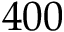<formula> <loc_0><loc_0><loc_500><loc_500>4 0 0</formula> 